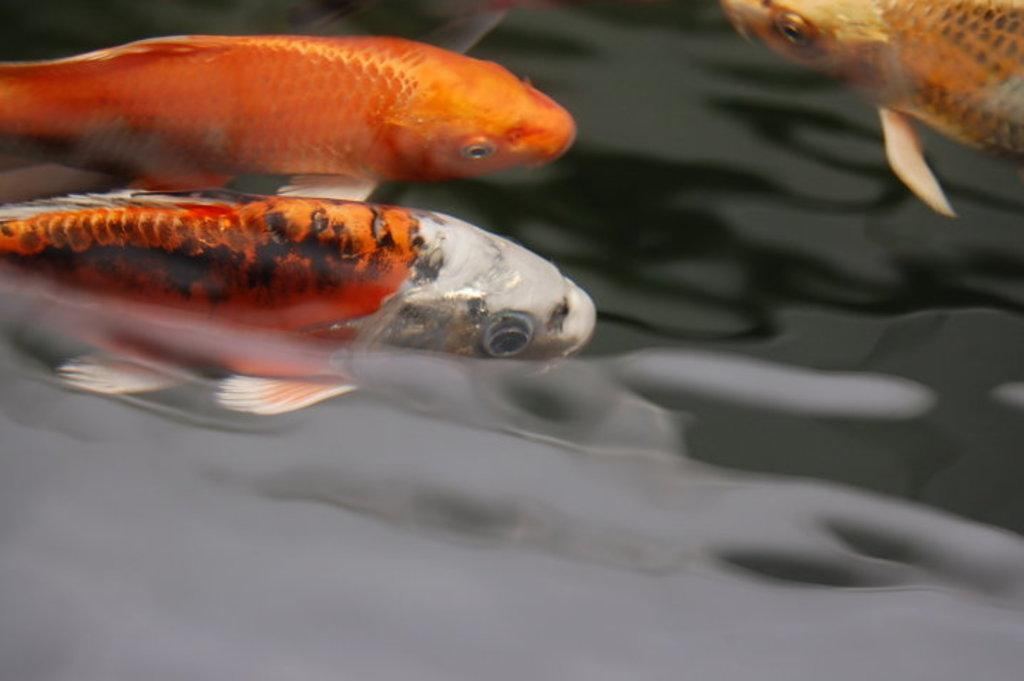What color are the fishes in the water? The fishes in the water are orange in color. What type of magic spell can be seen affecting the fishes in the image? There is no magic spell present in the image; it only features orange color fishes in the water. Can you describe the alley where the fishes are located in the image? There is no alley present in the image; it only features orange color fishes in the water. 